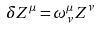Convert formula to latex. <formula><loc_0><loc_0><loc_500><loc_500>\delta Z ^ { \mu } = \omega _ { \nu } ^ { \mu } Z ^ { \nu }</formula> 